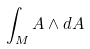Convert formula to latex. <formula><loc_0><loc_0><loc_500><loc_500>\int _ { M } A \wedge d A</formula> 